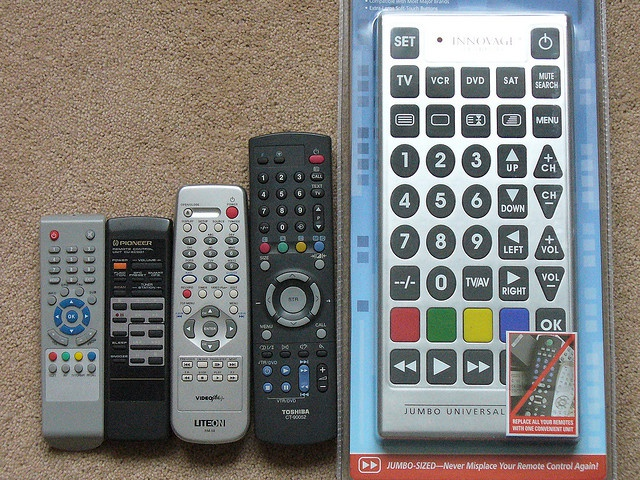Describe the objects in this image and their specific colors. I can see remote in gray, white, darkgray, and lightblue tones, remote in gray, black, and purple tones, remote in gray, darkgray, lightgray, and black tones, remote in gray, darkgray, and black tones, and remote in gray and black tones in this image. 